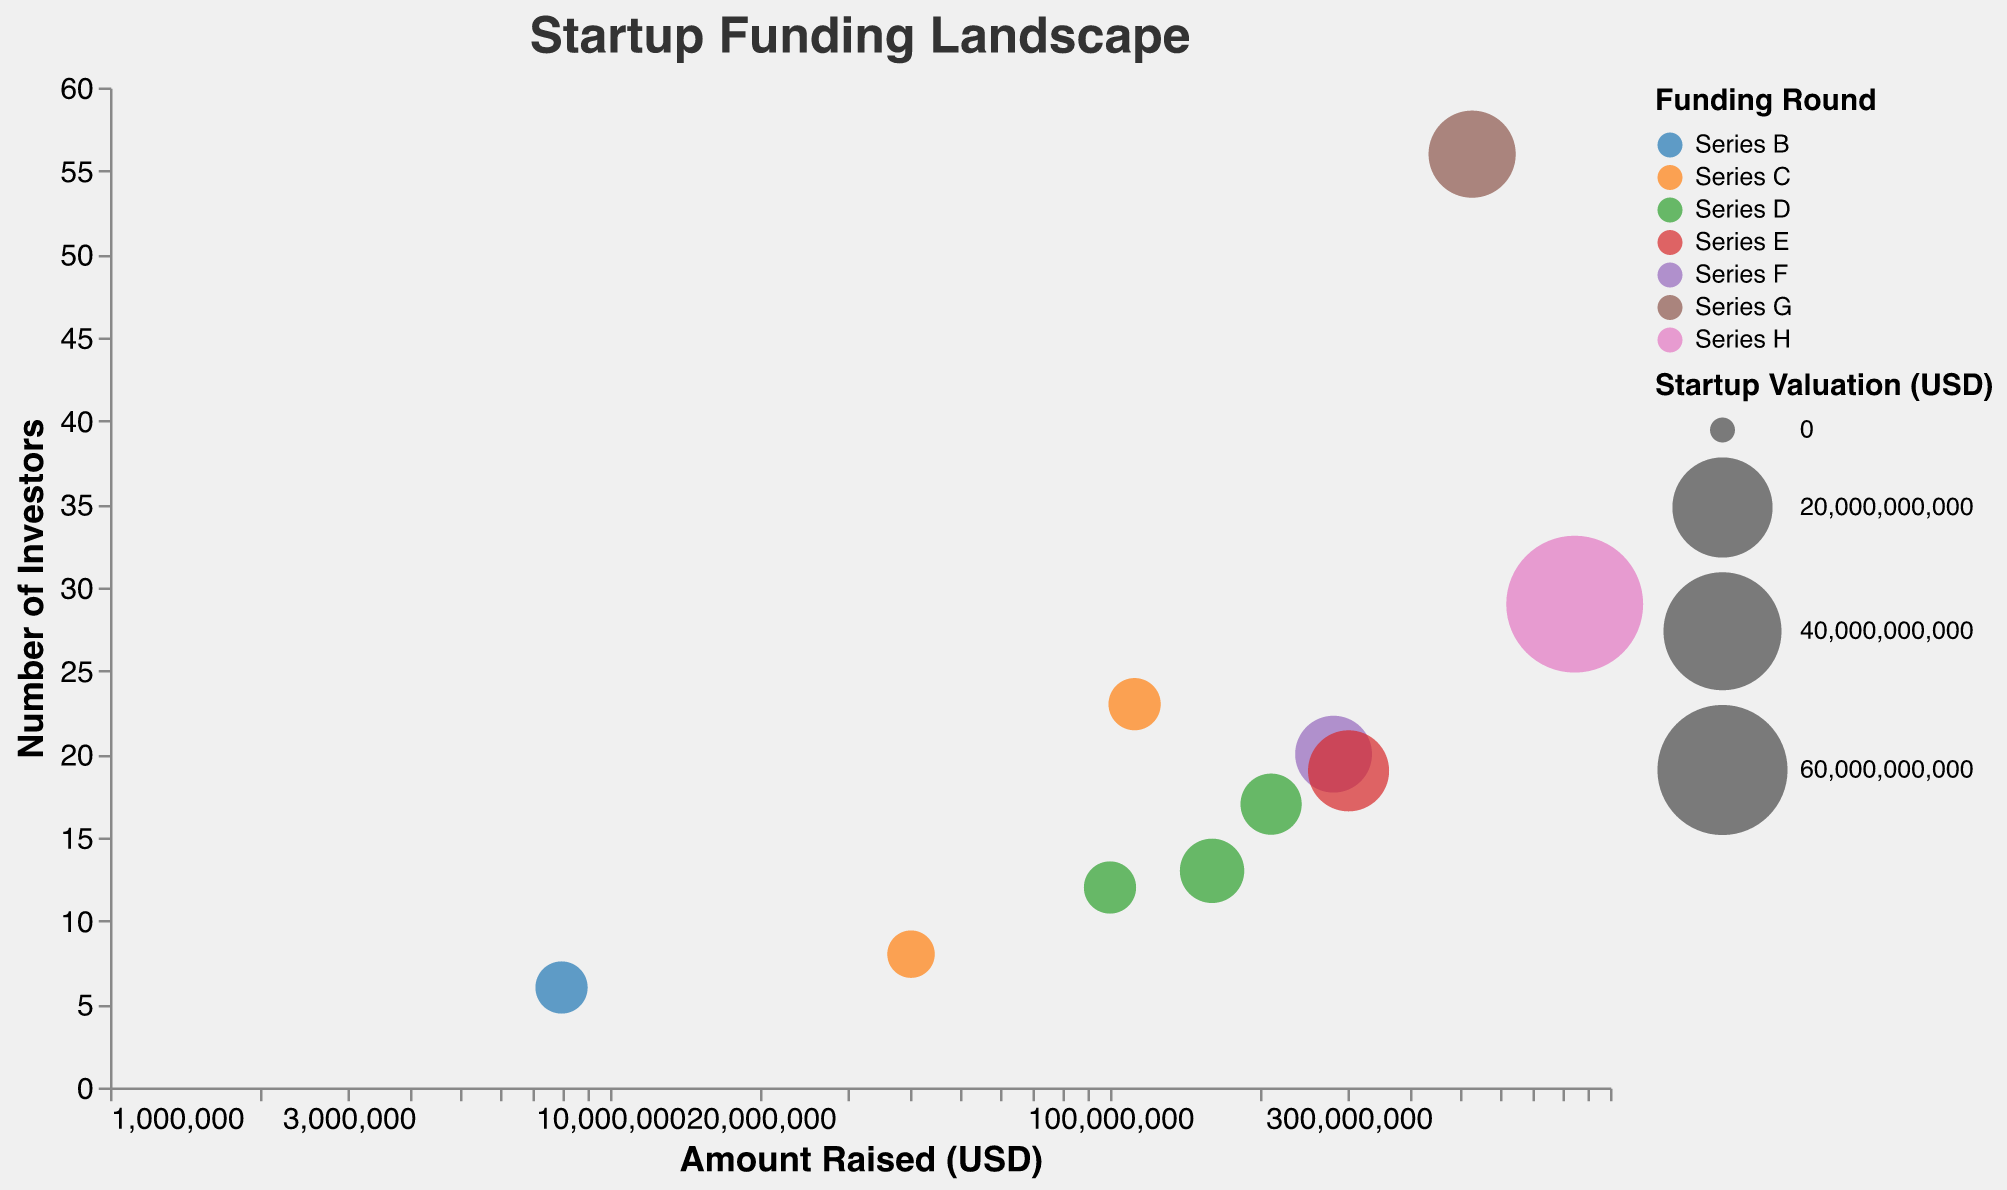How many startups are included in the bubble chart? The chart has one bubble for each startup. By counting the number of bubbles, we see there are 10 startups.
Answer: 10 Which startup has the highest valuation? By looking at the size of the bubbles and the legend, the largest bubble represents the highest valuation. The largest bubble corresponds to SpaceX, with a valuation of $74 billion.
Answer: SpaceX What is the relationship between the number of investors and the amount raised for Lyft? Locate the bubble for Lyft. It shows that Lyft raised $530 million with 56 investors.
Answer: Raised $530 million with 56 investors Which startup raised the most amount in Series F? Filter the bubbles by their color representing "Series F” funding round. The startup with the largest bubble among these is Robinhood, which raised $280 million.
Answer: Robinhood What's the average valuation of the startups? Sum all the valuations given for the startups: $1B (Airbnb) + $1B (Stripe) + $2.2B (Instacart) + $6.3B (Robinhood) + $74B (SpaceX) + $1B (Zoom) + $0.6B (DoorDash) + $8B (Coinbase) + $11B (Lyft) + $2.8B (Slack) = $108.9B. Then divide by the number of startups, 10: $108.9B / 10 = $10.89 billion.
Answer: $10.89 billion Compare the number of investors between Stripe and SpaceX. Locate the bubbles for both Stripe and SpaceX. Stripe has 6 investors, while SpaceX has 29 investors.
Answer: Stripe has fewer investors (6) than SpaceX (29) Which startup has a lower valuation, DoorDash or Zoom? Check the size of the bubbles for DoorDash and Zoom. DoorDash has a valuation of $600 million, whereas Zoom has a valuation of $1 billion.
Answer: DoorDash What's the common valuation seen among multiple startups? Checking bubble sizes and the tooltips shows that Airbnb, Stripe, and Zoom all have valuations of $1 billion.
Answer: $1 billion How is the amount raised by Coinbase compared to Instacart? Check the bubbles for Coinbase and Instacart. Coinbase raised $300 million while Instacart raised $210 million.
Answer: Coinbase raised more than Instacart What funding round has the least number of startups? Observe the legend and count the number of bubbles per funding round: Series H (1 startup - SpaceX).
Answer: Series H 